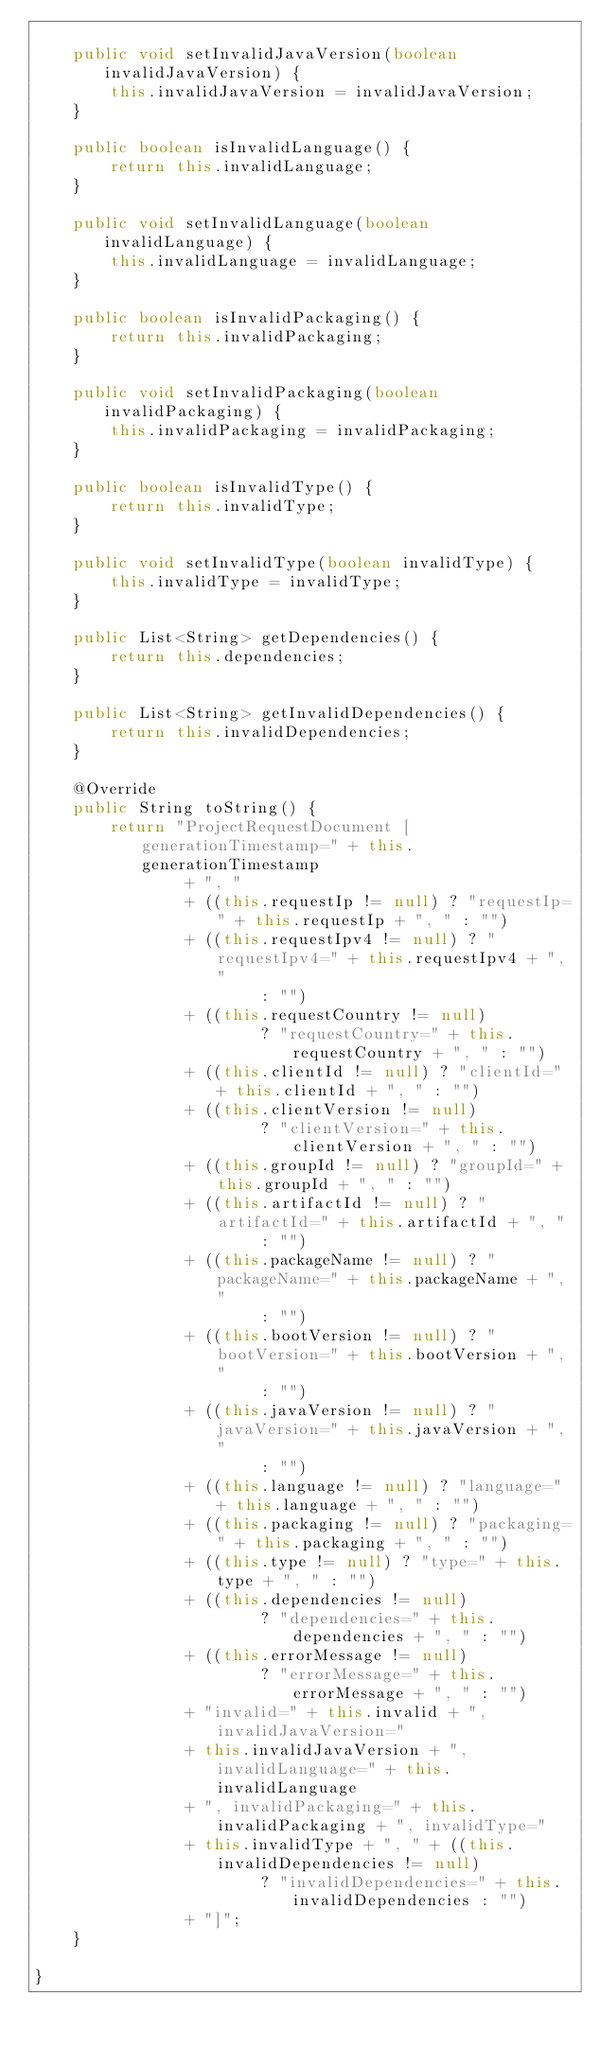<code> <loc_0><loc_0><loc_500><loc_500><_Java_>
	public void setInvalidJavaVersion(boolean invalidJavaVersion) {
		this.invalidJavaVersion = invalidJavaVersion;
	}

	public boolean isInvalidLanguage() {
		return this.invalidLanguage;
	}

	public void setInvalidLanguage(boolean invalidLanguage) {
		this.invalidLanguage = invalidLanguage;
	}

	public boolean isInvalidPackaging() {
		return this.invalidPackaging;
	}

	public void setInvalidPackaging(boolean invalidPackaging) {
		this.invalidPackaging = invalidPackaging;
	}

	public boolean isInvalidType() {
		return this.invalidType;
	}

	public void setInvalidType(boolean invalidType) {
		this.invalidType = invalidType;
	}

	public List<String> getDependencies() {
		return this.dependencies;
	}

	public List<String> getInvalidDependencies() {
		return this.invalidDependencies;
	}

	@Override
	public String toString() {
		return "ProjectRequestDocument [generationTimestamp=" + this.generationTimestamp
				+ ", "
				+ ((this.requestIp != null) ? "requestIp=" + this.requestIp + ", " : "")
				+ ((this.requestIpv4 != null) ? "requestIpv4=" + this.requestIpv4 + ", "
						: "")
				+ ((this.requestCountry != null)
						? "requestCountry=" + this.requestCountry + ", " : "")
				+ ((this.clientId != null) ? "clientId=" + this.clientId + ", " : "")
				+ ((this.clientVersion != null)
						? "clientVersion=" + this.clientVersion + ", " : "")
				+ ((this.groupId != null) ? "groupId=" + this.groupId + ", " : "")
				+ ((this.artifactId != null) ? "artifactId=" + this.artifactId + ", "
						: "")
				+ ((this.packageName != null) ? "packageName=" + this.packageName + ", "
						: "")
				+ ((this.bootVersion != null) ? "bootVersion=" + this.bootVersion + ", "
						: "")
				+ ((this.javaVersion != null) ? "javaVersion=" + this.javaVersion + ", "
						: "")
				+ ((this.language != null) ? "language=" + this.language + ", " : "")
				+ ((this.packaging != null) ? "packaging=" + this.packaging + ", " : "")
				+ ((this.type != null) ? "type=" + this.type + ", " : "")
				+ ((this.dependencies != null)
						? "dependencies=" + this.dependencies + ", " : "")
				+ ((this.errorMessage != null)
						? "errorMessage=" + this.errorMessage + ", " : "")
				+ "invalid=" + this.invalid + ", invalidJavaVersion="
				+ this.invalidJavaVersion + ", invalidLanguage=" + this.invalidLanguage
				+ ", invalidPackaging=" + this.invalidPackaging + ", invalidType="
				+ this.invalidType + ", " + ((this.invalidDependencies != null)
						? "invalidDependencies=" + this.invalidDependencies : "")
				+ "]";
	}

}
</code> 